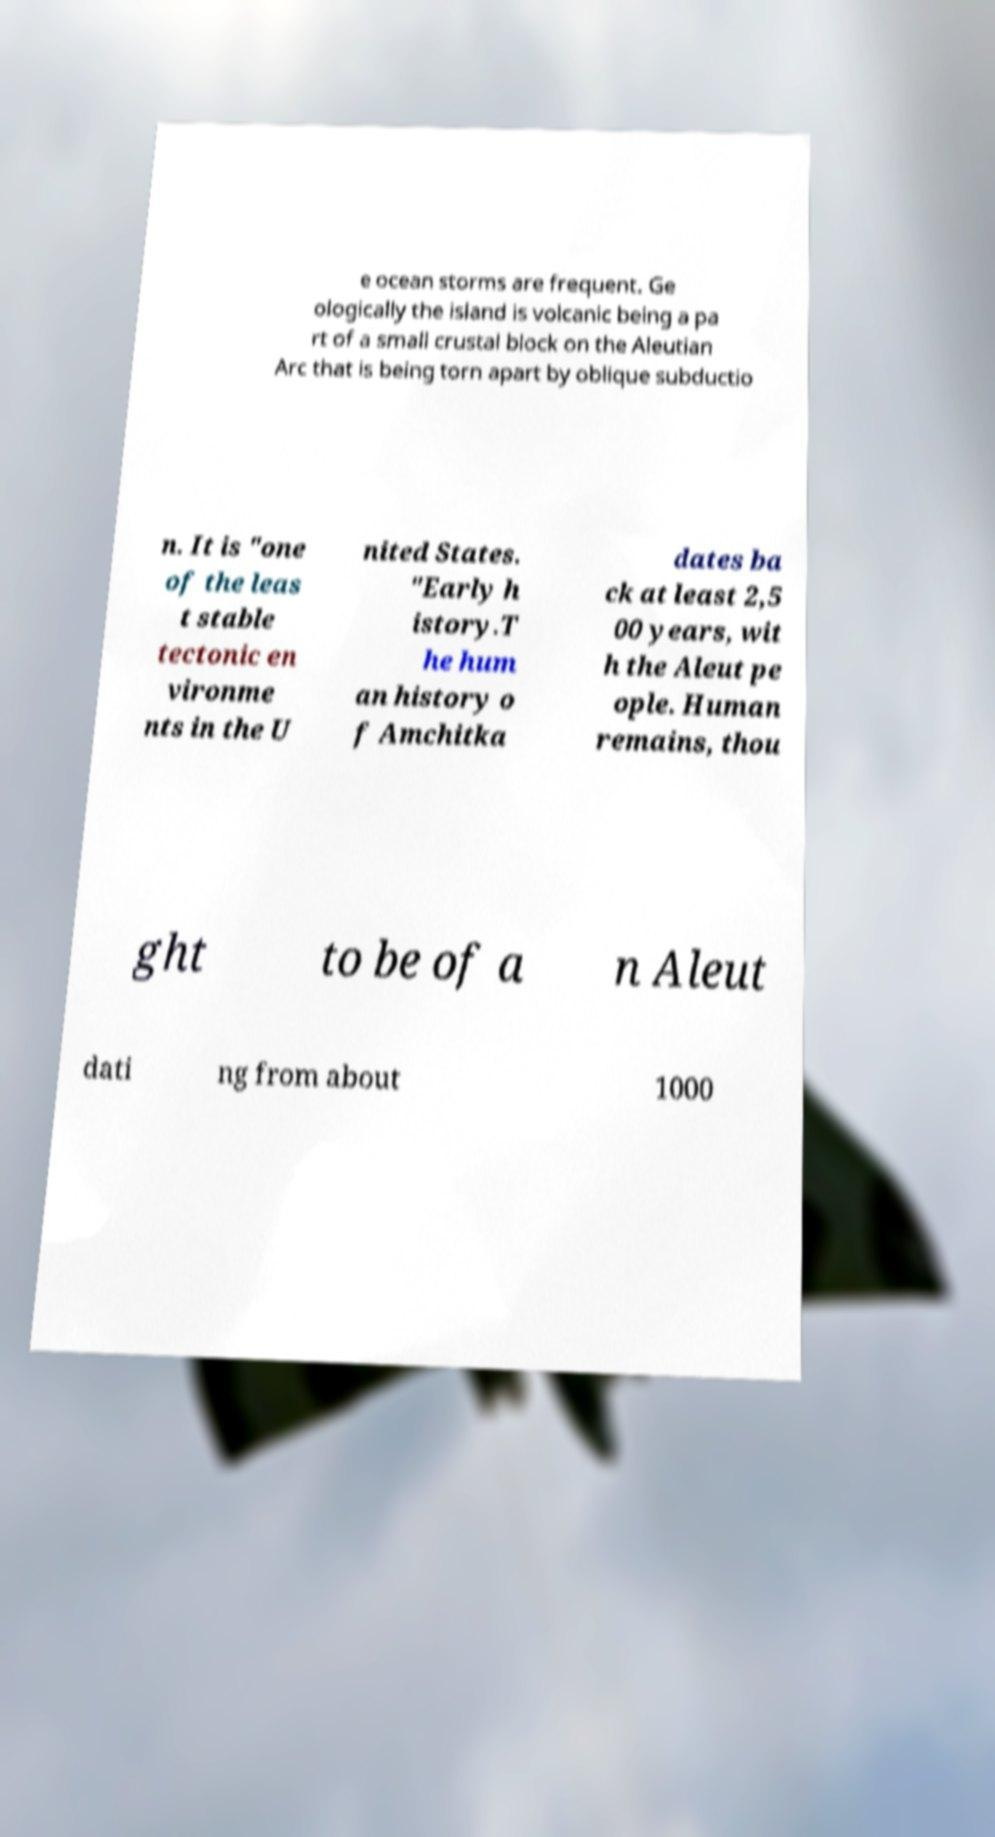Could you assist in decoding the text presented in this image and type it out clearly? e ocean storms are frequent. Ge ologically the island is volcanic being a pa rt of a small crustal block on the Aleutian Arc that is being torn apart by oblique subductio n. It is "one of the leas t stable tectonic en vironme nts in the U nited States. "Early h istory.T he hum an history o f Amchitka dates ba ck at least 2,5 00 years, wit h the Aleut pe ople. Human remains, thou ght to be of a n Aleut dati ng from about 1000 